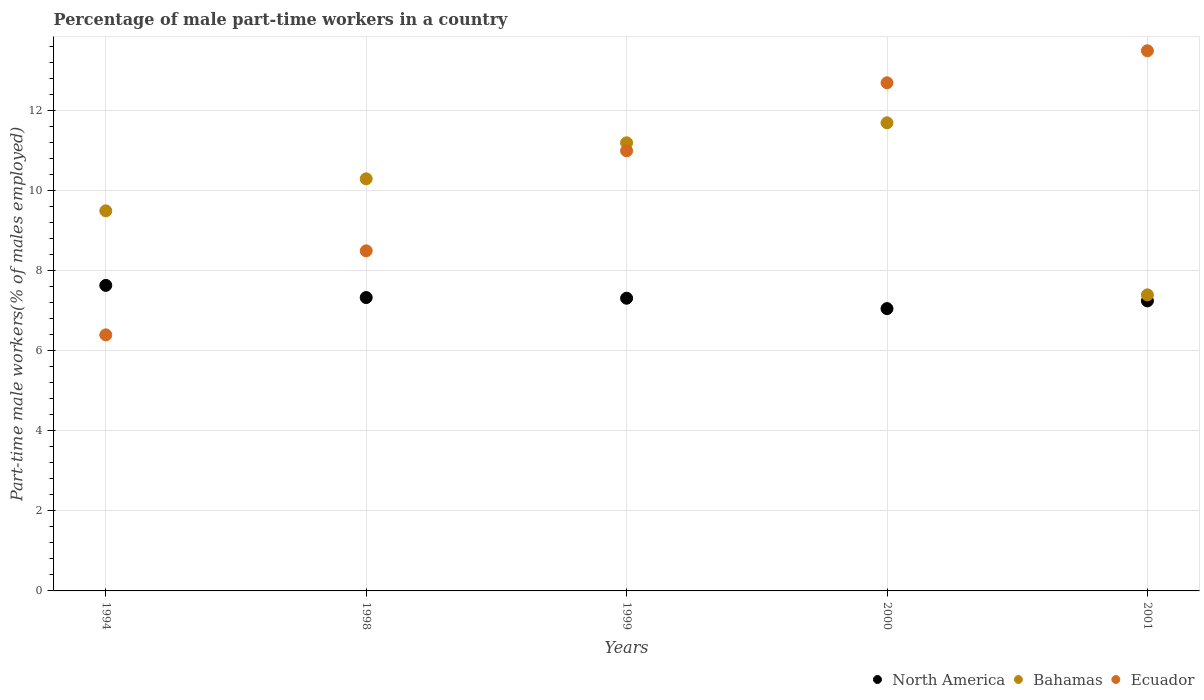How many different coloured dotlines are there?
Your answer should be very brief. 3. Is the number of dotlines equal to the number of legend labels?
Ensure brevity in your answer.  Yes. What is the percentage of male part-time workers in North America in 1994?
Provide a short and direct response. 7.64. Across all years, what is the maximum percentage of male part-time workers in Bahamas?
Ensure brevity in your answer.  11.7. Across all years, what is the minimum percentage of male part-time workers in Ecuador?
Provide a succinct answer. 6.4. In which year was the percentage of male part-time workers in Ecuador maximum?
Give a very brief answer. 2001. In which year was the percentage of male part-time workers in Bahamas minimum?
Your response must be concise. 2001. What is the total percentage of male part-time workers in North America in the graph?
Provide a short and direct response. 36.59. What is the difference between the percentage of male part-time workers in North America in 1998 and that in 2000?
Give a very brief answer. 0.28. What is the difference between the percentage of male part-time workers in Ecuador in 1994 and the percentage of male part-time workers in North America in 2001?
Keep it short and to the point. -0.85. What is the average percentage of male part-time workers in Ecuador per year?
Your answer should be very brief. 10.42. In the year 2000, what is the difference between the percentage of male part-time workers in Ecuador and percentage of male part-time workers in North America?
Give a very brief answer. 5.64. In how many years, is the percentage of male part-time workers in North America greater than 4 %?
Your answer should be very brief. 5. What is the ratio of the percentage of male part-time workers in North America in 1994 to that in 2000?
Your answer should be compact. 1.08. Is the percentage of male part-time workers in North America in 1994 less than that in 1999?
Offer a terse response. No. What is the difference between the highest and the second highest percentage of male part-time workers in North America?
Keep it short and to the point. 0.3. What is the difference between the highest and the lowest percentage of male part-time workers in Bahamas?
Offer a very short reply. 4.3. In how many years, is the percentage of male part-time workers in Bahamas greater than the average percentage of male part-time workers in Bahamas taken over all years?
Offer a very short reply. 3. Is the sum of the percentage of male part-time workers in Ecuador in 1994 and 1999 greater than the maximum percentage of male part-time workers in Bahamas across all years?
Provide a succinct answer. Yes. Is it the case that in every year, the sum of the percentage of male part-time workers in North America and percentage of male part-time workers in Bahamas  is greater than the percentage of male part-time workers in Ecuador?
Offer a terse response. Yes. Is the percentage of male part-time workers in Bahamas strictly less than the percentage of male part-time workers in Ecuador over the years?
Provide a short and direct response. No. How many dotlines are there?
Ensure brevity in your answer.  3. How many years are there in the graph?
Keep it short and to the point. 5. What is the difference between two consecutive major ticks on the Y-axis?
Keep it short and to the point. 2. Does the graph contain grids?
Offer a terse response. Yes. Where does the legend appear in the graph?
Offer a terse response. Bottom right. How many legend labels are there?
Provide a short and direct response. 3. What is the title of the graph?
Your answer should be compact. Percentage of male part-time workers in a country. What is the label or title of the X-axis?
Keep it short and to the point. Years. What is the label or title of the Y-axis?
Provide a succinct answer. Part-time male workers(% of males employed). What is the Part-time male workers(% of males employed) in North America in 1994?
Keep it short and to the point. 7.64. What is the Part-time male workers(% of males employed) in Ecuador in 1994?
Offer a terse response. 6.4. What is the Part-time male workers(% of males employed) of North America in 1998?
Provide a succinct answer. 7.33. What is the Part-time male workers(% of males employed) in Bahamas in 1998?
Your answer should be very brief. 10.3. What is the Part-time male workers(% of males employed) in Ecuador in 1998?
Make the answer very short. 8.5. What is the Part-time male workers(% of males employed) in North America in 1999?
Provide a short and direct response. 7.32. What is the Part-time male workers(% of males employed) of Bahamas in 1999?
Keep it short and to the point. 11.2. What is the Part-time male workers(% of males employed) of North America in 2000?
Your answer should be compact. 7.06. What is the Part-time male workers(% of males employed) of Bahamas in 2000?
Keep it short and to the point. 11.7. What is the Part-time male workers(% of males employed) in Ecuador in 2000?
Offer a terse response. 12.7. What is the Part-time male workers(% of males employed) in North America in 2001?
Give a very brief answer. 7.25. What is the Part-time male workers(% of males employed) of Bahamas in 2001?
Provide a succinct answer. 7.4. Across all years, what is the maximum Part-time male workers(% of males employed) of North America?
Provide a short and direct response. 7.64. Across all years, what is the maximum Part-time male workers(% of males employed) of Bahamas?
Your answer should be compact. 11.7. Across all years, what is the maximum Part-time male workers(% of males employed) in Ecuador?
Keep it short and to the point. 13.5. Across all years, what is the minimum Part-time male workers(% of males employed) in North America?
Make the answer very short. 7.06. Across all years, what is the minimum Part-time male workers(% of males employed) of Bahamas?
Your answer should be compact. 7.4. Across all years, what is the minimum Part-time male workers(% of males employed) of Ecuador?
Make the answer very short. 6.4. What is the total Part-time male workers(% of males employed) in North America in the graph?
Make the answer very short. 36.59. What is the total Part-time male workers(% of males employed) in Bahamas in the graph?
Your answer should be very brief. 50.1. What is the total Part-time male workers(% of males employed) in Ecuador in the graph?
Your answer should be compact. 52.1. What is the difference between the Part-time male workers(% of males employed) in North America in 1994 and that in 1998?
Offer a terse response. 0.3. What is the difference between the Part-time male workers(% of males employed) of Bahamas in 1994 and that in 1998?
Give a very brief answer. -0.8. What is the difference between the Part-time male workers(% of males employed) of Ecuador in 1994 and that in 1998?
Keep it short and to the point. -2.1. What is the difference between the Part-time male workers(% of males employed) of North America in 1994 and that in 1999?
Ensure brevity in your answer.  0.32. What is the difference between the Part-time male workers(% of males employed) in Bahamas in 1994 and that in 1999?
Offer a terse response. -1.7. What is the difference between the Part-time male workers(% of males employed) of North America in 1994 and that in 2000?
Your answer should be compact. 0.58. What is the difference between the Part-time male workers(% of males employed) in Bahamas in 1994 and that in 2000?
Offer a very short reply. -2.2. What is the difference between the Part-time male workers(% of males employed) in Ecuador in 1994 and that in 2000?
Provide a succinct answer. -6.3. What is the difference between the Part-time male workers(% of males employed) of North America in 1994 and that in 2001?
Give a very brief answer. 0.39. What is the difference between the Part-time male workers(% of males employed) of Bahamas in 1994 and that in 2001?
Provide a succinct answer. 2.1. What is the difference between the Part-time male workers(% of males employed) of Ecuador in 1994 and that in 2001?
Provide a succinct answer. -7.1. What is the difference between the Part-time male workers(% of males employed) of North America in 1998 and that in 1999?
Ensure brevity in your answer.  0.02. What is the difference between the Part-time male workers(% of males employed) of Ecuador in 1998 and that in 1999?
Keep it short and to the point. -2.5. What is the difference between the Part-time male workers(% of males employed) in North America in 1998 and that in 2000?
Your response must be concise. 0.28. What is the difference between the Part-time male workers(% of males employed) in Bahamas in 1998 and that in 2000?
Ensure brevity in your answer.  -1.4. What is the difference between the Part-time male workers(% of males employed) of North America in 1998 and that in 2001?
Keep it short and to the point. 0.08. What is the difference between the Part-time male workers(% of males employed) in Ecuador in 1998 and that in 2001?
Your answer should be compact. -5. What is the difference between the Part-time male workers(% of males employed) of North America in 1999 and that in 2000?
Your answer should be very brief. 0.26. What is the difference between the Part-time male workers(% of males employed) in Bahamas in 1999 and that in 2000?
Provide a short and direct response. -0.5. What is the difference between the Part-time male workers(% of males employed) in North America in 1999 and that in 2001?
Offer a terse response. 0.07. What is the difference between the Part-time male workers(% of males employed) in Bahamas in 1999 and that in 2001?
Give a very brief answer. 3.8. What is the difference between the Part-time male workers(% of males employed) in North America in 2000 and that in 2001?
Provide a short and direct response. -0.19. What is the difference between the Part-time male workers(% of males employed) of North America in 1994 and the Part-time male workers(% of males employed) of Bahamas in 1998?
Your answer should be very brief. -2.66. What is the difference between the Part-time male workers(% of males employed) of North America in 1994 and the Part-time male workers(% of males employed) of Ecuador in 1998?
Offer a terse response. -0.86. What is the difference between the Part-time male workers(% of males employed) in Bahamas in 1994 and the Part-time male workers(% of males employed) in Ecuador in 1998?
Offer a terse response. 1. What is the difference between the Part-time male workers(% of males employed) in North America in 1994 and the Part-time male workers(% of males employed) in Bahamas in 1999?
Provide a succinct answer. -3.56. What is the difference between the Part-time male workers(% of males employed) of North America in 1994 and the Part-time male workers(% of males employed) of Ecuador in 1999?
Provide a short and direct response. -3.36. What is the difference between the Part-time male workers(% of males employed) of Bahamas in 1994 and the Part-time male workers(% of males employed) of Ecuador in 1999?
Make the answer very short. -1.5. What is the difference between the Part-time male workers(% of males employed) of North America in 1994 and the Part-time male workers(% of males employed) of Bahamas in 2000?
Provide a succinct answer. -4.06. What is the difference between the Part-time male workers(% of males employed) of North America in 1994 and the Part-time male workers(% of males employed) of Ecuador in 2000?
Provide a short and direct response. -5.06. What is the difference between the Part-time male workers(% of males employed) of Bahamas in 1994 and the Part-time male workers(% of males employed) of Ecuador in 2000?
Offer a terse response. -3.2. What is the difference between the Part-time male workers(% of males employed) of North America in 1994 and the Part-time male workers(% of males employed) of Bahamas in 2001?
Offer a very short reply. 0.24. What is the difference between the Part-time male workers(% of males employed) in North America in 1994 and the Part-time male workers(% of males employed) in Ecuador in 2001?
Give a very brief answer. -5.86. What is the difference between the Part-time male workers(% of males employed) of North America in 1998 and the Part-time male workers(% of males employed) of Bahamas in 1999?
Provide a short and direct response. -3.87. What is the difference between the Part-time male workers(% of males employed) of North America in 1998 and the Part-time male workers(% of males employed) of Ecuador in 1999?
Provide a short and direct response. -3.67. What is the difference between the Part-time male workers(% of males employed) in North America in 1998 and the Part-time male workers(% of males employed) in Bahamas in 2000?
Give a very brief answer. -4.37. What is the difference between the Part-time male workers(% of males employed) of North America in 1998 and the Part-time male workers(% of males employed) of Ecuador in 2000?
Make the answer very short. -5.37. What is the difference between the Part-time male workers(% of males employed) of North America in 1998 and the Part-time male workers(% of males employed) of Bahamas in 2001?
Your response must be concise. -0.07. What is the difference between the Part-time male workers(% of males employed) in North America in 1998 and the Part-time male workers(% of males employed) in Ecuador in 2001?
Your response must be concise. -6.17. What is the difference between the Part-time male workers(% of males employed) of Bahamas in 1998 and the Part-time male workers(% of males employed) of Ecuador in 2001?
Your answer should be compact. -3.2. What is the difference between the Part-time male workers(% of males employed) of North America in 1999 and the Part-time male workers(% of males employed) of Bahamas in 2000?
Give a very brief answer. -4.38. What is the difference between the Part-time male workers(% of males employed) of North America in 1999 and the Part-time male workers(% of males employed) of Ecuador in 2000?
Keep it short and to the point. -5.38. What is the difference between the Part-time male workers(% of males employed) in North America in 1999 and the Part-time male workers(% of males employed) in Bahamas in 2001?
Ensure brevity in your answer.  -0.08. What is the difference between the Part-time male workers(% of males employed) of North America in 1999 and the Part-time male workers(% of males employed) of Ecuador in 2001?
Provide a succinct answer. -6.18. What is the difference between the Part-time male workers(% of males employed) of North America in 2000 and the Part-time male workers(% of males employed) of Bahamas in 2001?
Provide a short and direct response. -0.34. What is the difference between the Part-time male workers(% of males employed) in North America in 2000 and the Part-time male workers(% of males employed) in Ecuador in 2001?
Your response must be concise. -6.44. What is the average Part-time male workers(% of males employed) in North America per year?
Offer a terse response. 7.32. What is the average Part-time male workers(% of males employed) in Bahamas per year?
Provide a succinct answer. 10.02. What is the average Part-time male workers(% of males employed) of Ecuador per year?
Make the answer very short. 10.42. In the year 1994, what is the difference between the Part-time male workers(% of males employed) of North America and Part-time male workers(% of males employed) of Bahamas?
Provide a short and direct response. -1.86. In the year 1994, what is the difference between the Part-time male workers(% of males employed) in North America and Part-time male workers(% of males employed) in Ecuador?
Offer a terse response. 1.24. In the year 1994, what is the difference between the Part-time male workers(% of males employed) of Bahamas and Part-time male workers(% of males employed) of Ecuador?
Provide a succinct answer. 3.1. In the year 1998, what is the difference between the Part-time male workers(% of males employed) of North America and Part-time male workers(% of males employed) of Bahamas?
Your answer should be compact. -2.97. In the year 1998, what is the difference between the Part-time male workers(% of males employed) of North America and Part-time male workers(% of males employed) of Ecuador?
Your answer should be compact. -1.17. In the year 1999, what is the difference between the Part-time male workers(% of males employed) of North America and Part-time male workers(% of males employed) of Bahamas?
Make the answer very short. -3.88. In the year 1999, what is the difference between the Part-time male workers(% of males employed) of North America and Part-time male workers(% of males employed) of Ecuador?
Ensure brevity in your answer.  -3.68. In the year 1999, what is the difference between the Part-time male workers(% of males employed) of Bahamas and Part-time male workers(% of males employed) of Ecuador?
Offer a very short reply. 0.2. In the year 2000, what is the difference between the Part-time male workers(% of males employed) of North America and Part-time male workers(% of males employed) of Bahamas?
Your answer should be compact. -4.64. In the year 2000, what is the difference between the Part-time male workers(% of males employed) in North America and Part-time male workers(% of males employed) in Ecuador?
Offer a terse response. -5.64. In the year 2000, what is the difference between the Part-time male workers(% of males employed) of Bahamas and Part-time male workers(% of males employed) of Ecuador?
Keep it short and to the point. -1. In the year 2001, what is the difference between the Part-time male workers(% of males employed) of North America and Part-time male workers(% of males employed) of Bahamas?
Offer a terse response. -0.15. In the year 2001, what is the difference between the Part-time male workers(% of males employed) in North America and Part-time male workers(% of males employed) in Ecuador?
Offer a very short reply. -6.25. What is the ratio of the Part-time male workers(% of males employed) in North America in 1994 to that in 1998?
Your response must be concise. 1.04. What is the ratio of the Part-time male workers(% of males employed) in Bahamas in 1994 to that in 1998?
Your answer should be very brief. 0.92. What is the ratio of the Part-time male workers(% of males employed) in Ecuador in 1994 to that in 1998?
Make the answer very short. 0.75. What is the ratio of the Part-time male workers(% of males employed) of North America in 1994 to that in 1999?
Your answer should be compact. 1.04. What is the ratio of the Part-time male workers(% of males employed) of Bahamas in 1994 to that in 1999?
Offer a very short reply. 0.85. What is the ratio of the Part-time male workers(% of males employed) in Ecuador in 1994 to that in 1999?
Offer a terse response. 0.58. What is the ratio of the Part-time male workers(% of males employed) of North America in 1994 to that in 2000?
Offer a very short reply. 1.08. What is the ratio of the Part-time male workers(% of males employed) in Bahamas in 1994 to that in 2000?
Provide a short and direct response. 0.81. What is the ratio of the Part-time male workers(% of males employed) of Ecuador in 1994 to that in 2000?
Make the answer very short. 0.5. What is the ratio of the Part-time male workers(% of males employed) in North America in 1994 to that in 2001?
Provide a short and direct response. 1.05. What is the ratio of the Part-time male workers(% of males employed) in Bahamas in 1994 to that in 2001?
Provide a short and direct response. 1.28. What is the ratio of the Part-time male workers(% of males employed) of Ecuador in 1994 to that in 2001?
Offer a very short reply. 0.47. What is the ratio of the Part-time male workers(% of males employed) in Bahamas in 1998 to that in 1999?
Keep it short and to the point. 0.92. What is the ratio of the Part-time male workers(% of males employed) in Ecuador in 1998 to that in 1999?
Provide a short and direct response. 0.77. What is the ratio of the Part-time male workers(% of males employed) in North America in 1998 to that in 2000?
Provide a succinct answer. 1.04. What is the ratio of the Part-time male workers(% of males employed) in Bahamas in 1998 to that in 2000?
Keep it short and to the point. 0.88. What is the ratio of the Part-time male workers(% of males employed) of Ecuador in 1998 to that in 2000?
Your response must be concise. 0.67. What is the ratio of the Part-time male workers(% of males employed) of North America in 1998 to that in 2001?
Your response must be concise. 1.01. What is the ratio of the Part-time male workers(% of males employed) of Bahamas in 1998 to that in 2001?
Offer a very short reply. 1.39. What is the ratio of the Part-time male workers(% of males employed) in Ecuador in 1998 to that in 2001?
Keep it short and to the point. 0.63. What is the ratio of the Part-time male workers(% of males employed) in North America in 1999 to that in 2000?
Your answer should be compact. 1.04. What is the ratio of the Part-time male workers(% of males employed) in Bahamas in 1999 to that in 2000?
Your answer should be very brief. 0.96. What is the ratio of the Part-time male workers(% of males employed) of Ecuador in 1999 to that in 2000?
Make the answer very short. 0.87. What is the ratio of the Part-time male workers(% of males employed) in North America in 1999 to that in 2001?
Offer a very short reply. 1.01. What is the ratio of the Part-time male workers(% of males employed) in Bahamas in 1999 to that in 2001?
Offer a very short reply. 1.51. What is the ratio of the Part-time male workers(% of males employed) in Ecuador in 1999 to that in 2001?
Provide a succinct answer. 0.81. What is the ratio of the Part-time male workers(% of males employed) in North America in 2000 to that in 2001?
Offer a very short reply. 0.97. What is the ratio of the Part-time male workers(% of males employed) of Bahamas in 2000 to that in 2001?
Offer a terse response. 1.58. What is the ratio of the Part-time male workers(% of males employed) in Ecuador in 2000 to that in 2001?
Offer a very short reply. 0.94. What is the difference between the highest and the second highest Part-time male workers(% of males employed) in North America?
Give a very brief answer. 0.3. What is the difference between the highest and the second highest Part-time male workers(% of males employed) in Bahamas?
Make the answer very short. 0.5. What is the difference between the highest and the second highest Part-time male workers(% of males employed) in Ecuador?
Give a very brief answer. 0.8. What is the difference between the highest and the lowest Part-time male workers(% of males employed) of North America?
Provide a short and direct response. 0.58. 